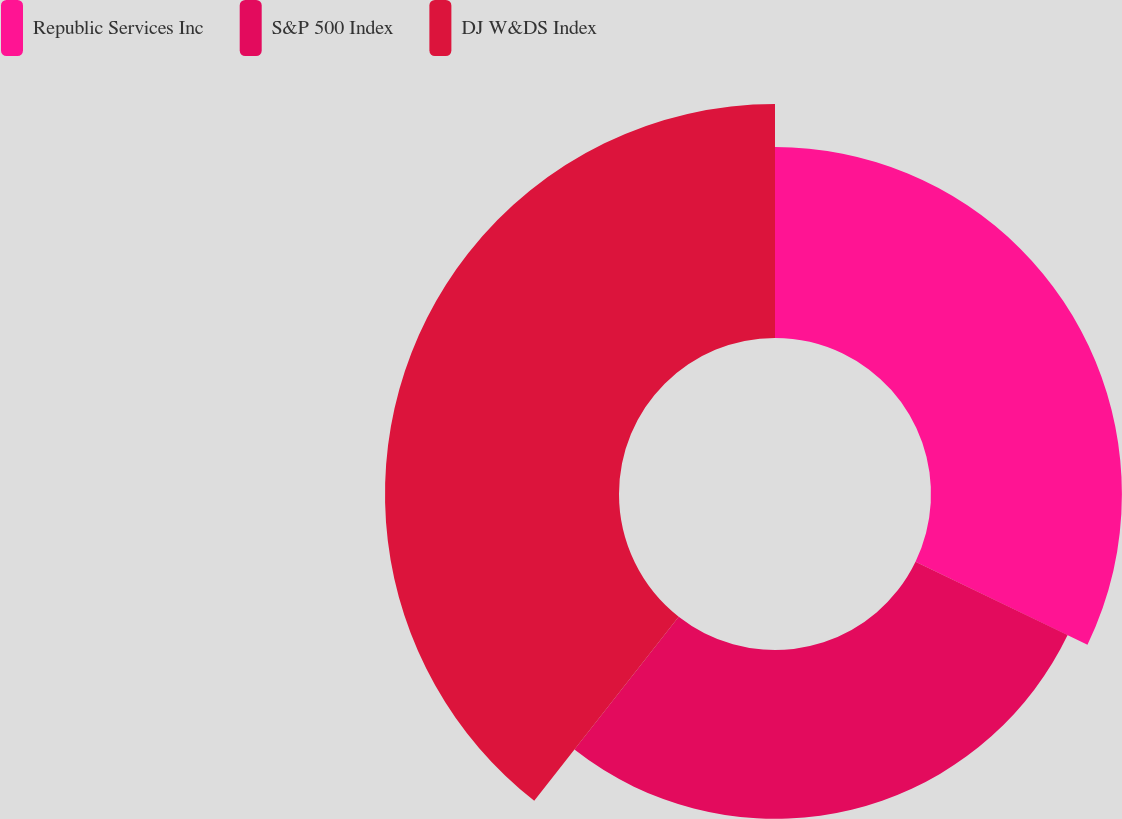Convert chart to OTSL. <chart><loc_0><loc_0><loc_500><loc_500><pie_chart><fcel>Republic Services Inc<fcel>S&P 500 Index<fcel>DJ W&DS Index<nl><fcel>32.15%<fcel>28.44%<fcel>39.41%<nl></chart> 